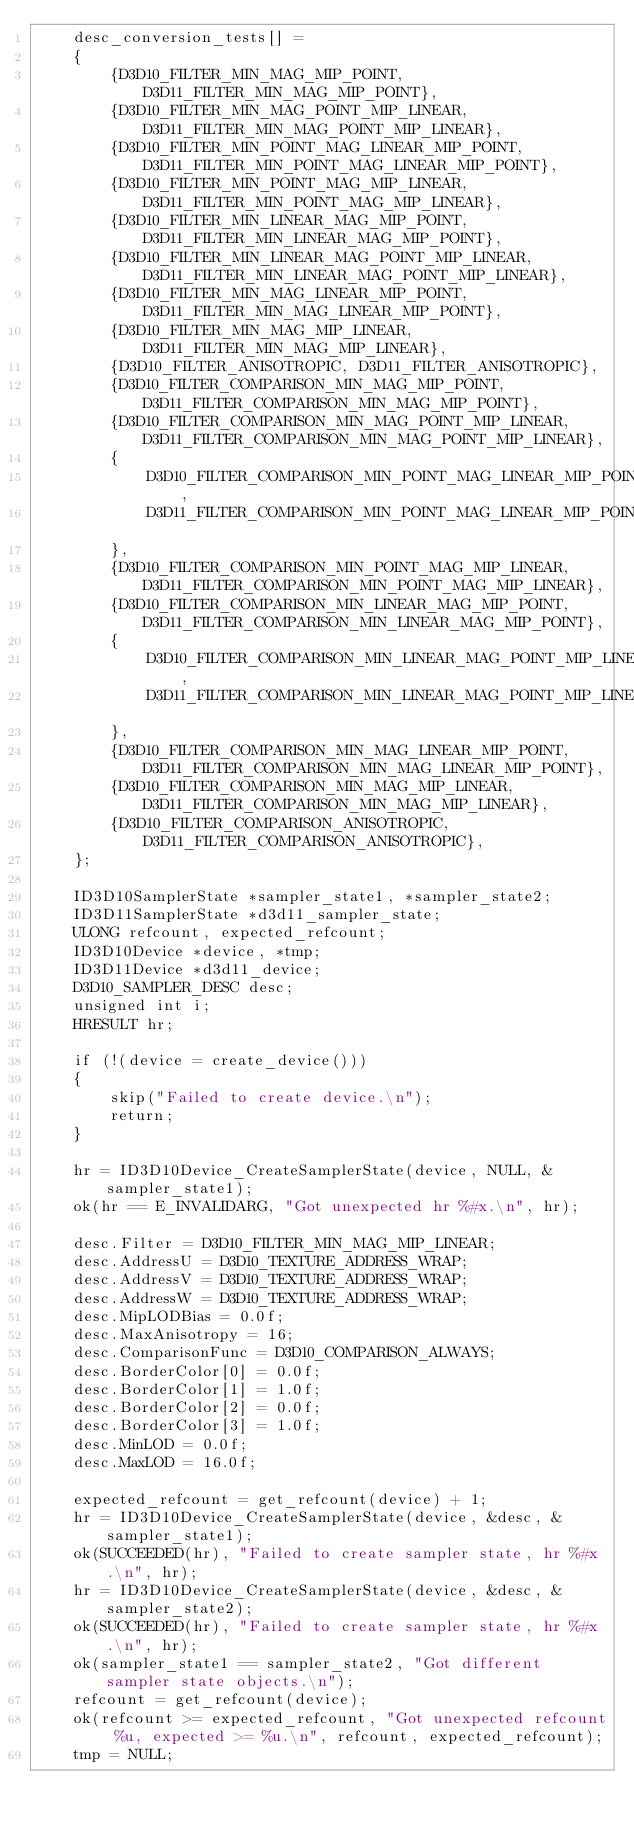<code> <loc_0><loc_0><loc_500><loc_500><_C_>    desc_conversion_tests[] =
    {
        {D3D10_FILTER_MIN_MAG_MIP_POINT, D3D11_FILTER_MIN_MAG_MIP_POINT},
        {D3D10_FILTER_MIN_MAG_POINT_MIP_LINEAR, D3D11_FILTER_MIN_MAG_POINT_MIP_LINEAR},
        {D3D10_FILTER_MIN_POINT_MAG_LINEAR_MIP_POINT, D3D11_FILTER_MIN_POINT_MAG_LINEAR_MIP_POINT},
        {D3D10_FILTER_MIN_POINT_MAG_MIP_LINEAR, D3D11_FILTER_MIN_POINT_MAG_MIP_LINEAR},
        {D3D10_FILTER_MIN_LINEAR_MAG_MIP_POINT, D3D11_FILTER_MIN_LINEAR_MAG_MIP_POINT},
        {D3D10_FILTER_MIN_LINEAR_MAG_POINT_MIP_LINEAR, D3D11_FILTER_MIN_LINEAR_MAG_POINT_MIP_LINEAR},
        {D3D10_FILTER_MIN_MAG_LINEAR_MIP_POINT, D3D11_FILTER_MIN_MAG_LINEAR_MIP_POINT},
        {D3D10_FILTER_MIN_MAG_MIP_LINEAR, D3D11_FILTER_MIN_MAG_MIP_LINEAR},
        {D3D10_FILTER_ANISOTROPIC, D3D11_FILTER_ANISOTROPIC},
        {D3D10_FILTER_COMPARISON_MIN_MAG_MIP_POINT, D3D11_FILTER_COMPARISON_MIN_MAG_MIP_POINT},
        {D3D10_FILTER_COMPARISON_MIN_MAG_POINT_MIP_LINEAR, D3D11_FILTER_COMPARISON_MIN_MAG_POINT_MIP_LINEAR},
        {
            D3D10_FILTER_COMPARISON_MIN_POINT_MAG_LINEAR_MIP_POINT,
            D3D11_FILTER_COMPARISON_MIN_POINT_MAG_LINEAR_MIP_POINT
        },
        {D3D10_FILTER_COMPARISON_MIN_POINT_MAG_MIP_LINEAR, D3D11_FILTER_COMPARISON_MIN_POINT_MAG_MIP_LINEAR},
        {D3D10_FILTER_COMPARISON_MIN_LINEAR_MAG_MIP_POINT, D3D11_FILTER_COMPARISON_MIN_LINEAR_MAG_MIP_POINT},
        {
            D3D10_FILTER_COMPARISON_MIN_LINEAR_MAG_POINT_MIP_LINEAR,
            D3D11_FILTER_COMPARISON_MIN_LINEAR_MAG_POINT_MIP_LINEAR
        },
        {D3D10_FILTER_COMPARISON_MIN_MAG_LINEAR_MIP_POINT, D3D11_FILTER_COMPARISON_MIN_MAG_LINEAR_MIP_POINT},
        {D3D10_FILTER_COMPARISON_MIN_MAG_MIP_LINEAR, D3D11_FILTER_COMPARISON_MIN_MAG_MIP_LINEAR},
        {D3D10_FILTER_COMPARISON_ANISOTROPIC, D3D11_FILTER_COMPARISON_ANISOTROPIC},
    };

    ID3D10SamplerState *sampler_state1, *sampler_state2;
    ID3D11SamplerState *d3d11_sampler_state;
    ULONG refcount, expected_refcount;
    ID3D10Device *device, *tmp;
    ID3D11Device *d3d11_device;
    D3D10_SAMPLER_DESC desc;
    unsigned int i;
    HRESULT hr;

    if (!(device = create_device()))
    {
        skip("Failed to create device.\n");
        return;
    }

    hr = ID3D10Device_CreateSamplerState(device, NULL, &sampler_state1);
    ok(hr == E_INVALIDARG, "Got unexpected hr %#x.\n", hr);

    desc.Filter = D3D10_FILTER_MIN_MAG_MIP_LINEAR;
    desc.AddressU = D3D10_TEXTURE_ADDRESS_WRAP;
    desc.AddressV = D3D10_TEXTURE_ADDRESS_WRAP;
    desc.AddressW = D3D10_TEXTURE_ADDRESS_WRAP;
    desc.MipLODBias = 0.0f;
    desc.MaxAnisotropy = 16;
    desc.ComparisonFunc = D3D10_COMPARISON_ALWAYS;
    desc.BorderColor[0] = 0.0f;
    desc.BorderColor[1] = 1.0f;
    desc.BorderColor[2] = 0.0f;
    desc.BorderColor[3] = 1.0f;
    desc.MinLOD = 0.0f;
    desc.MaxLOD = 16.0f;

    expected_refcount = get_refcount(device) + 1;
    hr = ID3D10Device_CreateSamplerState(device, &desc, &sampler_state1);
    ok(SUCCEEDED(hr), "Failed to create sampler state, hr %#x.\n", hr);
    hr = ID3D10Device_CreateSamplerState(device, &desc, &sampler_state2);
    ok(SUCCEEDED(hr), "Failed to create sampler state, hr %#x.\n", hr);
    ok(sampler_state1 == sampler_state2, "Got different sampler state objects.\n");
    refcount = get_refcount(device);
    ok(refcount >= expected_refcount, "Got unexpected refcount %u, expected >= %u.\n", refcount, expected_refcount);
    tmp = NULL;</code> 